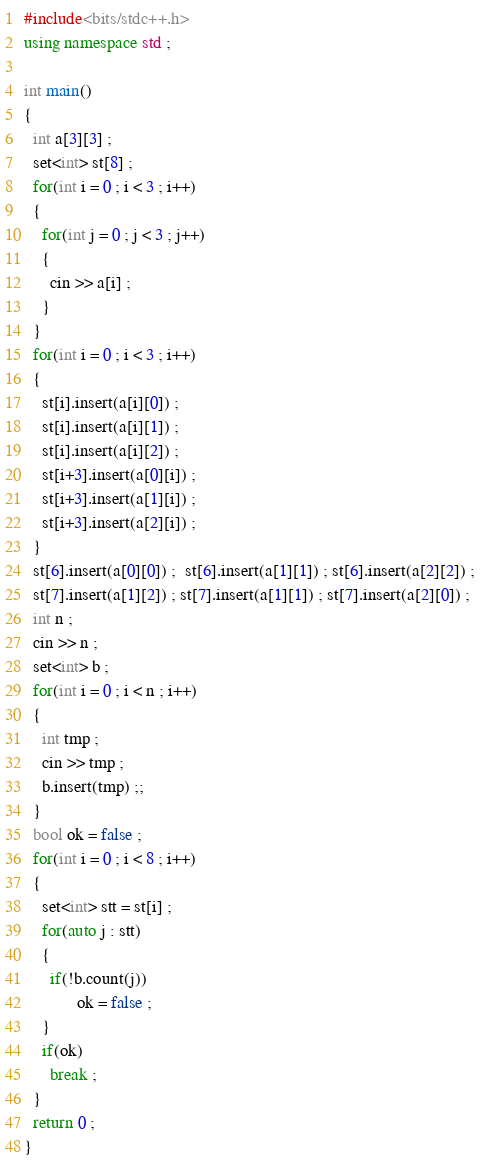Convert code to text. <code><loc_0><loc_0><loc_500><loc_500><_C++_>#include<bits/stdc++.h>
using namespace std ;
 
int main()
{
  int a[3][3] ;
  set<int> st[8] ;
  for(int i = 0 ; i < 3 ; i++)
  {
    for(int j = 0 ; j < 3 ; j++)
    {
      cin >> a[i] ;
    }
  }
  for(int i = 0 ; i < 3 ; i++)
  {
    st[i].insert(a[i][0]) ;
    st[i].insert(a[i][1]) ;
    st[i].insert(a[i][2]) ;
    st[i+3].insert(a[0][i]) ;
    st[i+3].insert(a[1][i]) ;
    st[i+3].insert(a[2][i]) ;
  }
  st[6].insert(a[0][0]) ;  st[6].insert(a[1][1]) ; st[6].insert(a[2][2]) ;
  st[7].insert(a[1][2]) ; st[7].insert(a[1][1]) ; st[7].insert(a[2][0]) ;
  int n ;
  cin >> n ;
  set<int> b ;
  for(int i = 0 ; i < n ; i++)
  {
    int tmp ;
    cin >> tmp ;
    b.insert(tmp) ;;
  }
  bool ok = false ;
  for(int i = 0 ; i < 8 ; i++)
  {
    set<int> stt = st[i] ;
    for(auto j : stt)
    {
      if(!b.count(j))
        	ok = false ;
    }
    if(ok)
      break ;
  }
  return 0 ;
}</code> 